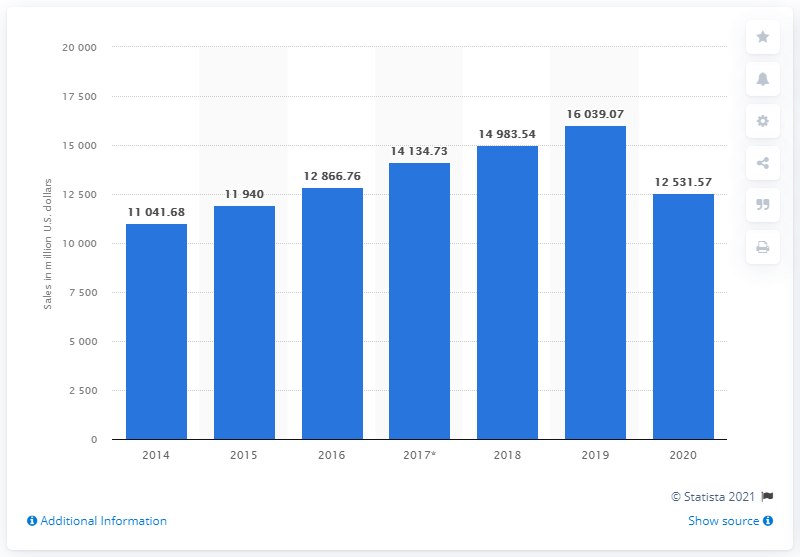Indicate a few pertinent items in this graphic. In 2020, the sales revenue of Ross Stores, Inc. was 12,531.57. 